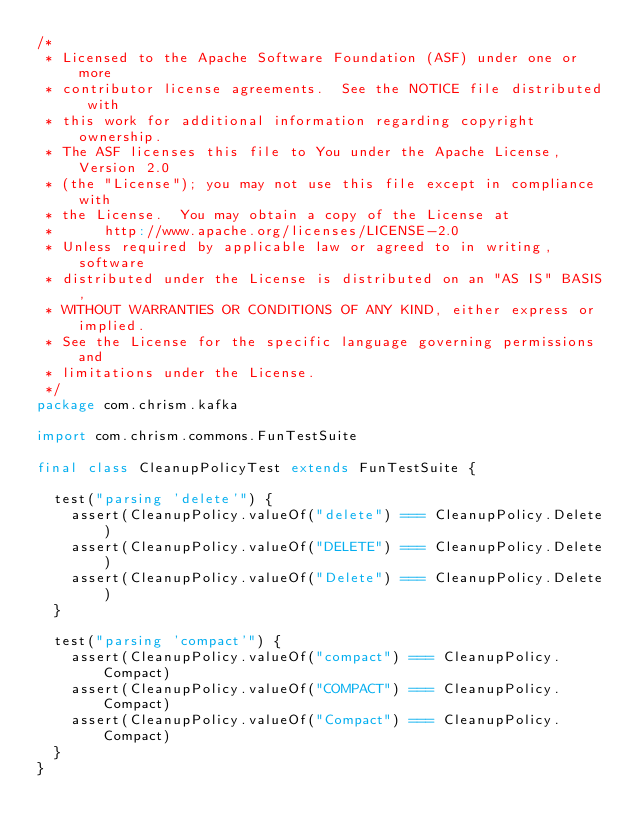<code> <loc_0><loc_0><loc_500><loc_500><_Scala_>/*
 * Licensed to the Apache Software Foundation (ASF) under one or more
 * contributor license agreements.  See the NOTICE file distributed with
 * this work for additional information regarding copyright ownership.
 * The ASF licenses this file to You under the Apache License, Version 2.0
 * (the "License"); you may not use this file except in compliance with
 * the License.  You may obtain a copy of the License at
 *      http://www.apache.org/licenses/LICENSE-2.0
 * Unless required by applicable law or agreed to in writing, software
 * distributed under the License is distributed on an "AS IS" BASIS,
 * WITHOUT WARRANTIES OR CONDITIONS OF ANY KIND, either express or implied.
 * See the License for the specific language governing permissions and
 * limitations under the License.
 */
package com.chrism.kafka

import com.chrism.commons.FunTestSuite

final class CleanupPolicyTest extends FunTestSuite {

  test("parsing 'delete'") {
    assert(CleanupPolicy.valueOf("delete") === CleanupPolicy.Delete)
    assert(CleanupPolicy.valueOf("DELETE") === CleanupPolicy.Delete)
    assert(CleanupPolicy.valueOf("Delete") === CleanupPolicy.Delete)
  }

  test("parsing 'compact'") {
    assert(CleanupPolicy.valueOf("compact") === CleanupPolicy.Compact)
    assert(CleanupPolicy.valueOf("COMPACT") === CleanupPolicy.Compact)
    assert(CleanupPolicy.valueOf("Compact") === CleanupPolicy.Compact)
  }
}
</code> 